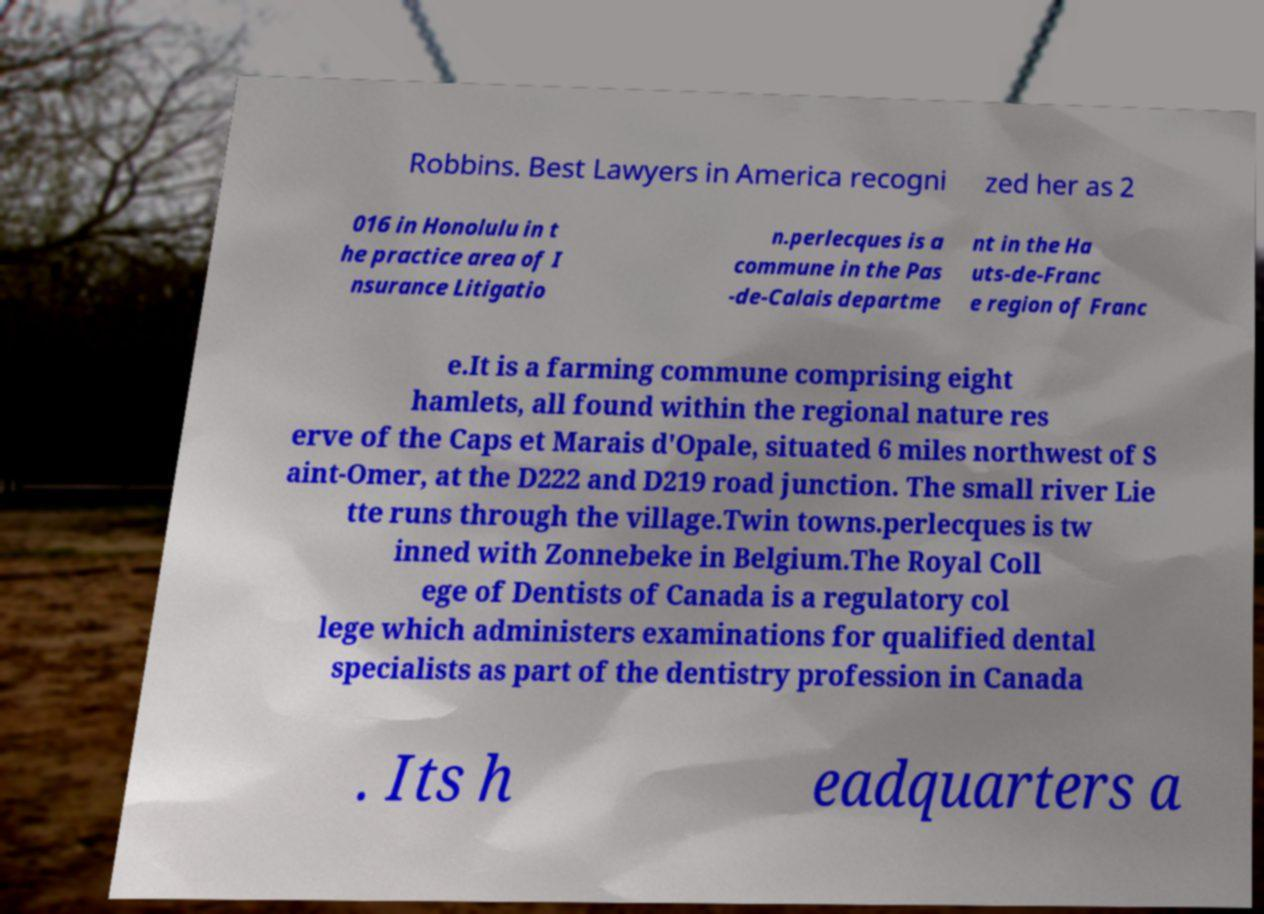There's text embedded in this image that I need extracted. Can you transcribe it verbatim? Robbins. Best Lawyers in America recogni zed her as 2 016 in Honolulu in t he practice area of I nsurance Litigatio n.perlecques is a commune in the Pas -de-Calais departme nt in the Ha uts-de-Franc e region of Franc e.It is a farming commune comprising eight hamlets, all found within the regional nature res erve of the Caps et Marais d'Opale, situated 6 miles northwest of S aint-Omer, at the D222 and D219 road junction. The small river Lie tte runs through the village.Twin towns.perlecques is tw inned with Zonnebeke in Belgium.The Royal Coll ege of Dentists of Canada is a regulatory col lege which administers examinations for qualified dental specialists as part of the dentistry profession in Canada . Its h eadquarters a 